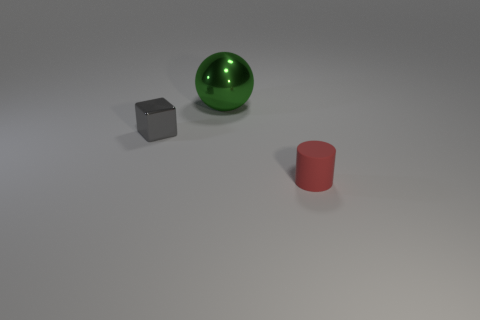The small thing right of the large metal ball behind the tiny object behind the tiny red cylinder is what shape?
Your answer should be very brief. Cylinder. Are there any other objects that have the same size as the red object?
Provide a succinct answer. Yes. What is the size of the gray block?
Your answer should be very brief. Small. How many red rubber cylinders have the same size as the gray metallic object?
Ensure brevity in your answer.  1. Are there fewer small cylinders behind the cylinder than red cylinders right of the gray metallic block?
Ensure brevity in your answer.  Yes. There is a shiny thing that is behind the small thing behind the tiny object that is on the right side of the tiny metal cube; how big is it?
Provide a short and direct response. Large. What is the size of the object that is both left of the small matte object and to the right of the gray metallic thing?
Your response must be concise. Large. There is a tiny thing on the right side of the small object behind the red object; what is its shape?
Keep it short and to the point. Cylinder. Is there anything else that is the same color as the cylinder?
Make the answer very short. No. What is the shape of the small thing that is on the left side of the small red rubber cylinder?
Provide a short and direct response. Cube. 